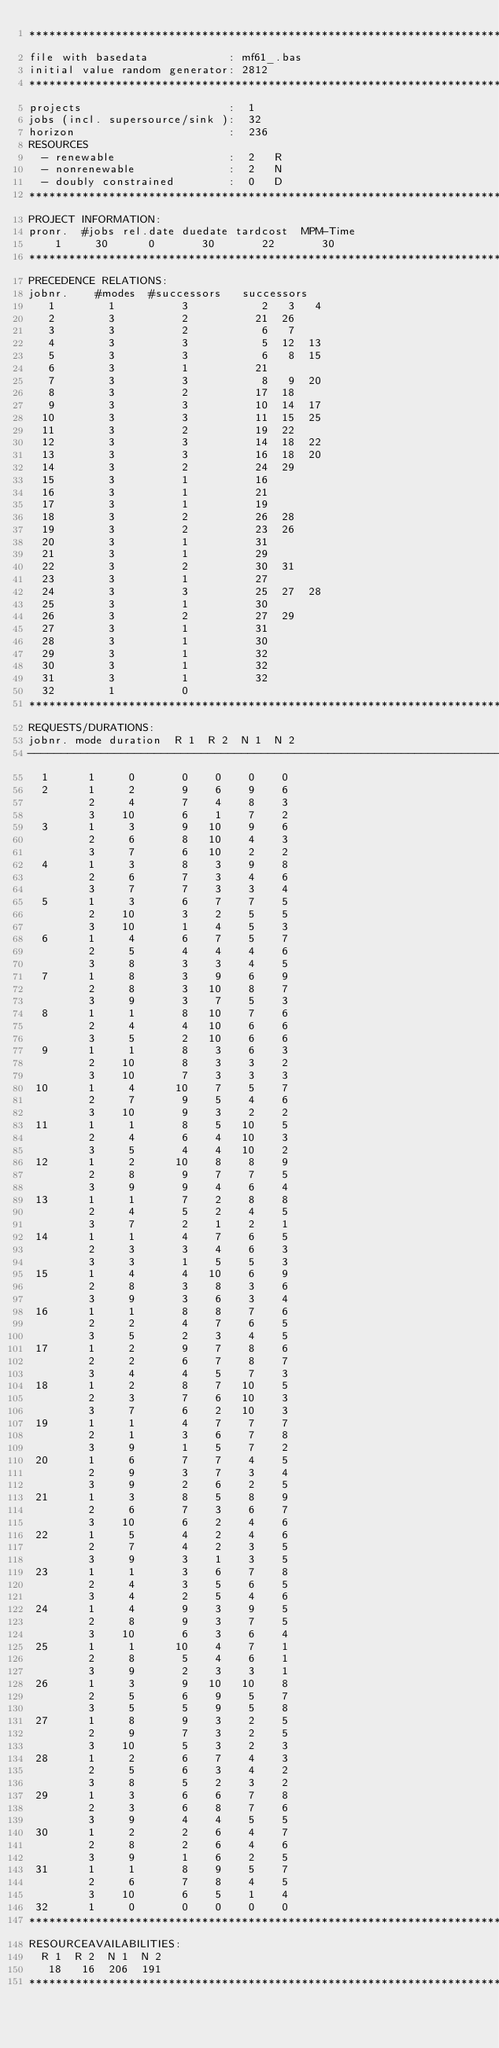Convert code to text. <code><loc_0><loc_0><loc_500><loc_500><_ObjectiveC_>************************************************************************
file with basedata            : mf61_.bas
initial value random generator: 2812
************************************************************************
projects                      :  1
jobs (incl. supersource/sink ):  32
horizon                       :  236
RESOURCES
  - renewable                 :  2   R
  - nonrenewable              :  2   N
  - doubly constrained        :  0   D
************************************************************************
PROJECT INFORMATION:
pronr.  #jobs rel.date duedate tardcost  MPM-Time
    1     30      0       30       22       30
************************************************************************
PRECEDENCE RELATIONS:
jobnr.    #modes  #successors   successors
   1        1          3           2   3   4
   2        3          2          21  26
   3        3          2           6   7
   4        3          3           5  12  13
   5        3          3           6   8  15
   6        3          1          21
   7        3          3           8   9  20
   8        3          2          17  18
   9        3          3          10  14  17
  10        3          3          11  15  25
  11        3          2          19  22
  12        3          3          14  18  22
  13        3          3          16  18  20
  14        3          2          24  29
  15        3          1          16
  16        3          1          21
  17        3          1          19
  18        3          2          26  28
  19        3          2          23  26
  20        3          1          31
  21        3          1          29
  22        3          2          30  31
  23        3          1          27
  24        3          3          25  27  28
  25        3          1          30
  26        3          2          27  29
  27        3          1          31
  28        3          1          30
  29        3          1          32
  30        3          1          32
  31        3          1          32
  32        1          0        
************************************************************************
REQUESTS/DURATIONS:
jobnr. mode duration  R 1  R 2  N 1  N 2
------------------------------------------------------------------------
  1      1     0       0    0    0    0
  2      1     2       9    6    9    6
         2     4       7    4    8    3
         3    10       6    1    7    2
  3      1     3       9   10    9    6
         2     6       8   10    4    3
         3     7       6   10    2    2
  4      1     3       8    3    9    8
         2     6       7    3    4    6
         3     7       7    3    3    4
  5      1     3       6    7    7    5
         2    10       3    2    5    5
         3    10       1    4    5    3
  6      1     4       6    7    5    7
         2     5       4    4    4    6
         3     8       3    3    4    5
  7      1     8       3    9    6    9
         2     8       3   10    8    7
         3     9       3    7    5    3
  8      1     1       8   10    7    6
         2     4       4   10    6    6
         3     5       2   10    6    6
  9      1     1       8    3    6    3
         2    10       8    3    3    2
         3    10       7    3    3    3
 10      1     4      10    7    5    7
         2     7       9    5    4    6
         3    10       9    3    2    2
 11      1     1       8    5   10    5
         2     4       6    4   10    3
         3     5       4    4   10    2
 12      1     2      10    8    8    9
         2     8       9    7    7    5
         3     9       9    4    6    4
 13      1     1       7    2    8    8
         2     4       5    2    4    5
         3     7       2    1    2    1
 14      1     1       4    7    6    5
         2     3       3    4    6    3
         3     3       1    5    5    3
 15      1     4       4   10    6    9
         2     8       3    8    3    6
         3     9       3    6    3    4
 16      1     1       8    8    7    6
         2     2       4    7    6    5
         3     5       2    3    4    5
 17      1     2       9    7    8    6
         2     2       6    7    8    7
         3     4       4    5    7    3
 18      1     2       8    7   10    5
         2     3       7    6   10    3
         3     7       6    2   10    3
 19      1     1       4    7    7    7
         2     1       3    6    7    8
         3     9       1    5    7    2
 20      1     6       7    7    4    5
         2     9       3    7    3    4
         3     9       2    6    2    5
 21      1     3       8    5    8    9
         2     6       7    3    6    7
         3    10       6    2    4    6
 22      1     5       4    2    4    6
         2     7       4    2    3    5
         3     9       3    1    3    5
 23      1     1       3    6    7    8
         2     4       3    5    6    5
         3     4       2    5    4    6
 24      1     4       9    3    9    5
         2     8       9    3    7    5
         3    10       6    3    6    4
 25      1     1      10    4    7    1
         2     8       5    4    6    1
         3     9       2    3    3    1
 26      1     3       9   10   10    8
         2     5       6    9    5    7
         3     5       5    9    5    8
 27      1     8       9    3    2    5
         2     9       7    3    2    5
         3    10       5    3    2    3
 28      1     2       6    7    4    3
         2     5       6    3    4    2
         3     8       5    2    3    2
 29      1     3       6    6    7    8
         2     3       6    8    7    6
         3     9       4    4    5    5
 30      1     2       2    6    4    7
         2     8       2    6    4    6
         3     9       1    6    2    5
 31      1     1       8    9    5    7
         2     6       7    8    4    5
         3    10       6    5    1    4
 32      1     0       0    0    0    0
************************************************************************
RESOURCEAVAILABILITIES:
  R 1  R 2  N 1  N 2
   18   16  206  191
************************************************************************
</code> 